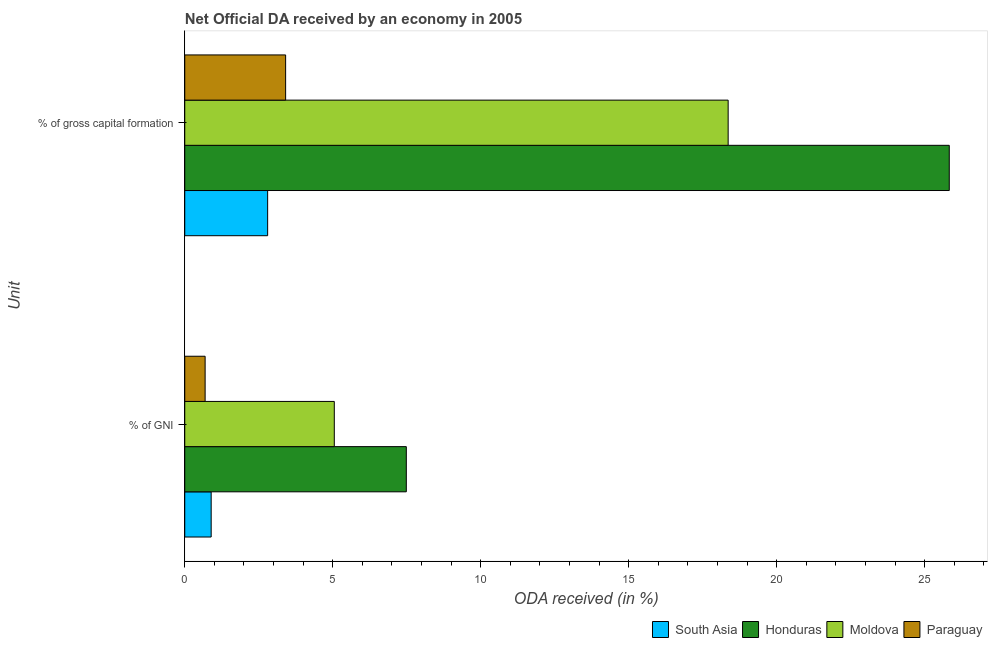Are the number of bars per tick equal to the number of legend labels?
Your answer should be very brief. Yes. Are the number of bars on each tick of the Y-axis equal?
Provide a short and direct response. Yes. How many bars are there on the 2nd tick from the top?
Provide a short and direct response. 4. How many bars are there on the 2nd tick from the bottom?
Keep it short and to the point. 4. What is the label of the 2nd group of bars from the top?
Ensure brevity in your answer.  % of GNI. What is the oda received as percentage of gni in Paraguay?
Offer a very short reply. 0.69. Across all countries, what is the maximum oda received as percentage of gni?
Provide a short and direct response. 7.49. Across all countries, what is the minimum oda received as percentage of gross capital formation?
Your answer should be compact. 2.8. In which country was the oda received as percentage of gross capital formation maximum?
Keep it short and to the point. Honduras. In which country was the oda received as percentage of gni minimum?
Offer a very short reply. Paraguay. What is the total oda received as percentage of gni in the graph?
Make the answer very short. 14.12. What is the difference between the oda received as percentage of gross capital formation in Honduras and that in South Asia?
Offer a very short reply. 23.03. What is the difference between the oda received as percentage of gni in South Asia and the oda received as percentage of gross capital formation in Moldova?
Your response must be concise. -17.47. What is the average oda received as percentage of gross capital formation per country?
Your response must be concise. 12.6. What is the difference between the oda received as percentage of gni and oda received as percentage of gross capital formation in Moldova?
Provide a succinct answer. -13.31. In how many countries, is the oda received as percentage of gross capital formation greater than 16 %?
Provide a short and direct response. 2. What is the ratio of the oda received as percentage of gross capital formation in South Asia to that in Honduras?
Your response must be concise. 0.11. In how many countries, is the oda received as percentage of gni greater than the average oda received as percentage of gni taken over all countries?
Offer a terse response. 2. What does the 1st bar from the top in % of GNI represents?
Give a very brief answer. Paraguay. What does the 3rd bar from the bottom in % of gross capital formation represents?
Your answer should be very brief. Moldova. How many bars are there?
Provide a short and direct response. 8. Are all the bars in the graph horizontal?
Give a very brief answer. Yes. Are the values on the major ticks of X-axis written in scientific E-notation?
Keep it short and to the point. No. Does the graph contain grids?
Give a very brief answer. No. Where does the legend appear in the graph?
Provide a short and direct response. Bottom right. How many legend labels are there?
Provide a short and direct response. 4. How are the legend labels stacked?
Make the answer very short. Horizontal. What is the title of the graph?
Your answer should be compact. Net Official DA received by an economy in 2005. What is the label or title of the X-axis?
Your response must be concise. ODA received (in %). What is the label or title of the Y-axis?
Keep it short and to the point. Unit. What is the ODA received (in %) of South Asia in % of GNI?
Make the answer very short. 0.89. What is the ODA received (in %) in Honduras in % of GNI?
Offer a very short reply. 7.49. What is the ODA received (in %) in Moldova in % of GNI?
Provide a succinct answer. 5.05. What is the ODA received (in %) of Paraguay in % of GNI?
Your response must be concise. 0.69. What is the ODA received (in %) of South Asia in % of gross capital formation?
Make the answer very short. 2.8. What is the ODA received (in %) in Honduras in % of gross capital formation?
Provide a succinct answer. 25.83. What is the ODA received (in %) of Moldova in % of gross capital formation?
Your answer should be compact. 18.36. What is the ODA received (in %) in Paraguay in % of gross capital formation?
Make the answer very short. 3.41. Across all Unit, what is the maximum ODA received (in %) of South Asia?
Ensure brevity in your answer.  2.8. Across all Unit, what is the maximum ODA received (in %) of Honduras?
Your answer should be very brief. 25.83. Across all Unit, what is the maximum ODA received (in %) in Moldova?
Ensure brevity in your answer.  18.36. Across all Unit, what is the maximum ODA received (in %) in Paraguay?
Offer a very short reply. 3.41. Across all Unit, what is the minimum ODA received (in %) of South Asia?
Your response must be concise. 0.89. Across all Unit, what is the minimum ODA received (in %) in Honduras?
Your answer should be compact. 7.49. Across all Unit, what is the minimum ODA received (in %) in Moldova?
Your answer should be very brief. 5.05. Across all Unit, what is the minimum ODA received (in %) in Paraguay?
Your answer should be very brief. 0.69. What is the total ODA received (in %) in South Asia in the graph?
Offer a terse response. 3.69. What is the total ODA received (in %) of Honduras in the graph?
Provide a short and direct response. 33.31. What is the total ODA received (in %) of Moldova in the graph?
Offer a terse response. 23.41. What is the total ODA received (in %) in Paraguay in the graph?
Give a very brief answer. 4.1. What is the difference between the ODA received (in %) of South Asia in % of GNI and that in % of gross capital formation?
Your response must be concise. -1.91. What is the difference between the ODA received (in %) of Honduras in % of GNI and that in % of gross capital formation?
Keep it short and to the point. -18.34. What is the difference between the ODA received (in %) in Moldova in % of GNI and that in % of gross capital formation?
Offer a very short reply. -13.31. What is the difference between the ODA received (in %) in Paraguay in % of GNI and that in % of gross capital formation?
Offer a very short reply. -2.72. What is the difference between the ODA received (in %) of South Asia in % of GNI and the ODA received (in %) of Honduras in % of gross capital formation?
Offer a terse response. -24.94. What is the difference between the ODA received (in %) of South Asia in % of GNI and the ODA received (in %) of Moldova in % of gross capital formation?
Give a very brief answer. -17.47. What is the difference between the ODA received (in %) in South Asia in % of GNI and the ODA received (in %) in Paraguay in % of gross capital formation?
Give a very brief answer. -2.52. What is the difference between the ODA received (in %) of Honduras in % of GNI and the ODA received (in %) of Moldova in % of gross capital formation?
Keep it short and to the point. -10.87. What is the difference between the ODA received (in %) in Honduras in % of GNI and the ODA received (in %) in Paraguay in % of gross capital formation?
Your response must be concise. 4.08. What is the difference between the ODA received (in %) of Moldova in % of GNI and the ODA received (in %) of Paraguay in % of gross capital formation?
Offer a terse response. 1.64. What is the average ODA received (in %) of South Asia per Unit?
Offer a terse response. 1.85. What is the average ODA received (in %) in Honduras per Unit?
Your answer should be compact. 16.66. What is the average ODA received (in %) of Moldova per Unit?
Your response must be concise. 11.71. What is the average ODA received (in %) of Paraguay per Unit?
Ensure brevity in your answer.  2.05. What is the difference between the ODA received (in %) in South Asia and ODA received (in %) in Honduras in % of GNI?
Ensure brevity in your answer.  -6.59. What is the difference between the ODA received (in %) in South Asia and ODA received (in %) in Moldova in % of GNI?
Provide a short and direct response. -4.16. What is the difference between the ODA received (in %) in South Asia and ODA received (in %) in Paraguay in % of GNI?
Provide a short and direct response. 0.2. What is the difference between the ODA received (in %) of Honduras and ODA received (in %) of Moldova in % of GNI?
Your answer should be compact. 2.43. What is the difference between the ODA received (in %) of Honduras and ODA received (in %) of Paraguay in % of GNI?
Ensure brevity in your answer.  6.8. What is the difference between the ODA received (in %) in Moldova and ODA received (in %) in Paraguay in % of GNI?
Offer a very short reply. 4.36. What is the difference between the ODA received (in %) of South Asia and ODA received (in %) of Honduras in % of gross capital formation?
Your response must be concise. -23.03. What is the difference between the ODA received (in %) in South Asia and ODA received (in %) in Moldova in % of gross capital formation?
Ensure brevity in your answer.  -15.56. What is the difference between the ODA received (in %) of South Asia and ODA received (in %) of Paraguay in % of gross capital formation?
Offer a terse response. -0.61. What is the difference between the ODA received (in %) in Honduras and ODA received (in %) in Moldova in % of gross capital formation?
Offer a terse response. 7.47. What is the difference between the ODA received (in %) in Honduras and ODA received (in %) in Paraguay in % of gross capital formation?
Ensure brevity in your answer.  22.42. What is the difference between the ODA received (in %) of Moldova and ODA received (in %) of Paraguay in % of gross capital formation?
Your answer should be compact. 14.95. What is the ratio of the ODA received (in %) of South Asia in % of GNI to that in % of gross capital formation?
Give a very brief answer. 0.32. What is the ratio of the ODA received (in %) in Honduras in % of GNI to that in % of gross capital formation?
Offer a terse response. 0.29. What is the ratio of the ODA received (in %) of Moldova in % of GNI to that in % of gross capital formation?
Give a very brief answer. 0.28. What is the ratio of the ODA received (in %) of Paraguay in % of GNI to that in % of gross capital formation?
Your answer should be compact. 0.2. What is the difference between the highest and the second highest ODA received (in %) of South Asia?
Give a very brief answer. 1.91. What is the difference between the highest and the second highest ODA received (in %) of Honduras?
Give a very brief answer. 18.34. What is the difference between the highest and the second highest ODA received (in %) in Moldova?
Your answer should be very brief. 13.31. What is the difference between the highest and the second highest ODA received (in %) of Paraguay?
Your response must be concise. 2.72. What is the difference between the highest and the lowest ODA received (in %) of South Asia?
Your response must be concise. 1.91. What is the difference between the highest and the lowest ODA received (in %) in Honduras?
Ensure brevity in your answer.  18.34. What is the difference between the highest and the lowest ODA received (in %) of Moldova?
Make the answer very short. 13.31. What is the difference between the highest and the lowest ODA received (in %) of Paraguay?
Keep it short and to the point. 2.72. 